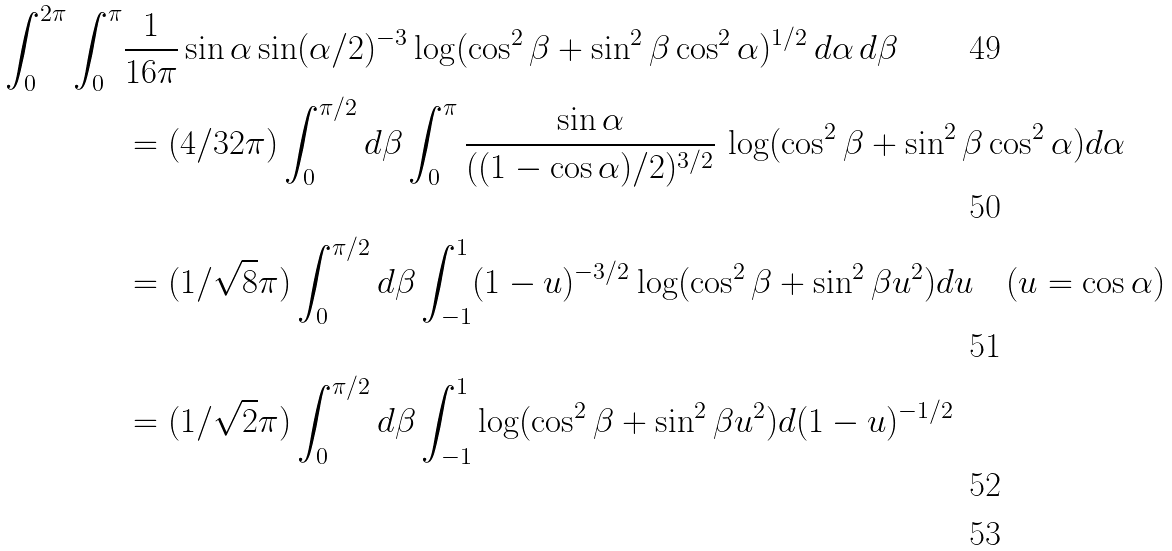Convert formula to latex. <formula><loc_0><loc_0><loc_500><loc_500>\int _ { 0 } ^ { 2 \pi } \int _ { 0 } ^ { \pi } & \frac { 1 } { 1 6 \pi } \sin \alpha \sin ( \alpha / 2 ) ^ { - 3 } \log ( \cos ^ { 2 } \beta + \sin ^ { 2 } \beta \cos ^ { 2 } \alpha ) ^ { 1 / 2 } \, d \alpha \, d \beta \\ & = ( 4 / 3 2 \pi ) \int _ { 0 } ^ { \pi / 2 } d \beta \int _ { 0 } ^ { \pi } \frac { \sin \alpha } { ( ( 1 - \cos \alpha ) / 2 ) ^ { 3 / 2 } } \, \log ( \cos ^ { 2 } \beta + \sin ^ { 2 } \beta \cos ^ { 2 } \alpha ) d \alpha \\ & = ( 1 / \sqrt { 8 } \pi ) \int _ { 0 } ^ { \pi / 2 } d \beta \int _ { - 1 } ^ { 1 } ( 1 - u ) ^ { - 3 / 2 } \log ( \cos ^ { 2 } \beta + \sin ^ { 2 } \beta u ^ { 2 } ) d u \quad ( u = \cos \alpha ) \\ & = ( 1 / \sqrt { 2 } \pi ) \int _ { 0 } ^ { \pi / 2 } d \beta \int _ { - 1 } ^ { 1 } \log ( \cos ^ { 2 } \beta + \sin ^ { 2 } \beta u ^ { 2 } ) d ( 1 - u ) ^ { - 1 / 2 } \\</formula> 